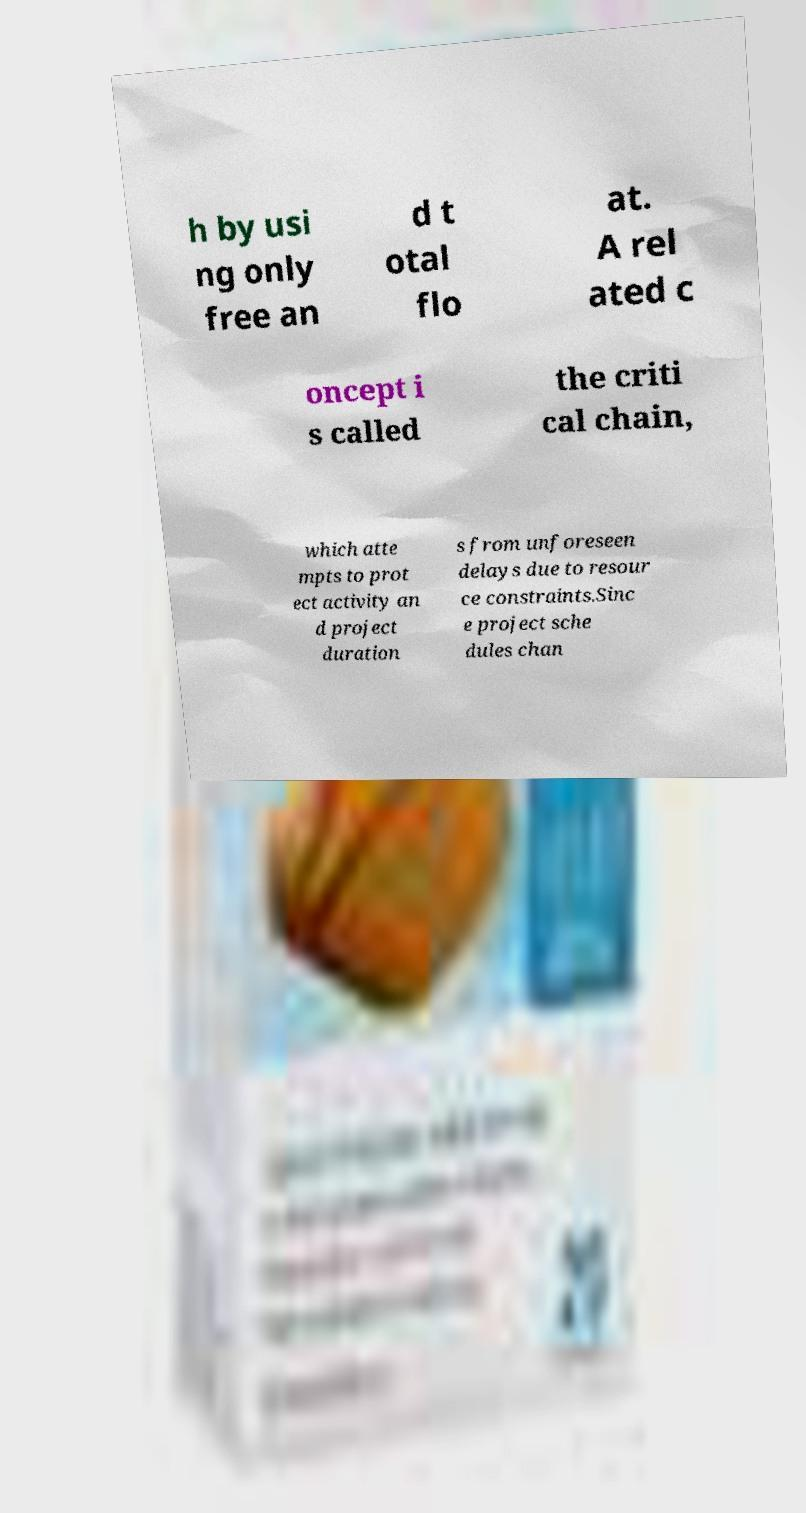Please read and relay the text visible in this image. What does it say? h by usi ng only free an d t otal flo at. A rel ated c oncept i s called the criti cal chain, which atte mpts to prot ect activity an d project duration s from unforeseen delays due to resour ce constraints.Sinc e project sche dules chan 